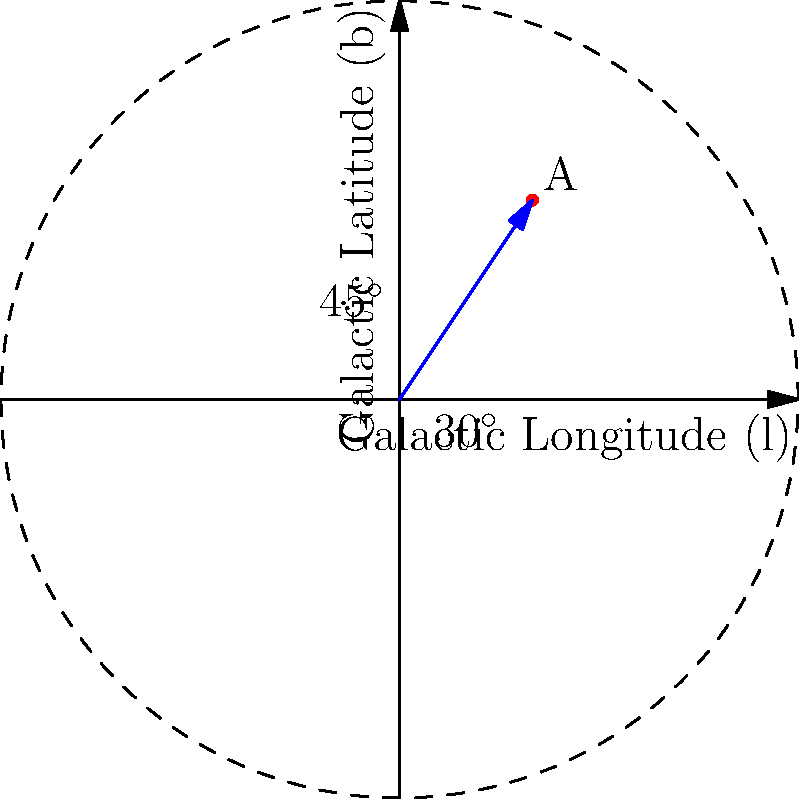Given a celestial object A with galactic coordinates $(l, b) = (30^\circ, 45^\circ)$, calculate its declination ($\delta$) in the equatorial coordinate system. Assume the following transformation parameters:
- North Galactic Pole: $\alpha_{NGP} = 192.85948^\circ$, $\delta_{NGP} = 27.12825^\circ$
- Galactic longitude of the ascending node: $l_\Omega = 32.93192^\circ$

Round your answer to the nearest arcminute. To convert from galactic coordinates $(l, b)$ to equatorial coordinates $(\alpha, \delta)$, we use the following steps:

1) First, we need to use the transformation equation for declination:

   $\sin\delta = \sin\delta_{NGP}\sin b + \cos\delta_{NGP}\cos b \cos(l - l_\Omega)$

2) Substituting the given values:
   $\sin\delta = \sin(27.12825^\circ)\sin(45^\circ) + \cos(27.12825^\circ)\cos(45^\circ)\cos(30^\circ - 32.93192^\circ)$

3) Calculate each term:
   $\sin(27.12825^\circ) = 0.4561$
   $\sin(45^\circ) = 0.7071$
   $\cos(27.12825^\circ) = 0.8899$
   $\cos(45^\circ) = 0.7071$
   $\cos(30^\circ - 32.93192^\circ) = \cos(-2.93192^\circ) = 0.9987$

4) Substitute these values:
   $\sin\delta = (0.4561 \times 0.7071) + (0.8899 \times 0.7071 \times 0.9987)$
   $\sin\delta = 0.3225 + 0.6285 = 0.9510$

5) To get $\delta$, we need to take the inverse sine (arcsin):
   $\delta = \arcsin(0.9510) = 71.9965^\circ$

6) Rounding to the nearest arcminute:
   $71.9965^\circ \times 60 = 4319.79'$
   Rounded: $4320'$ or $72^\circ 0'$
Answer: $72^\circ 0'$ 